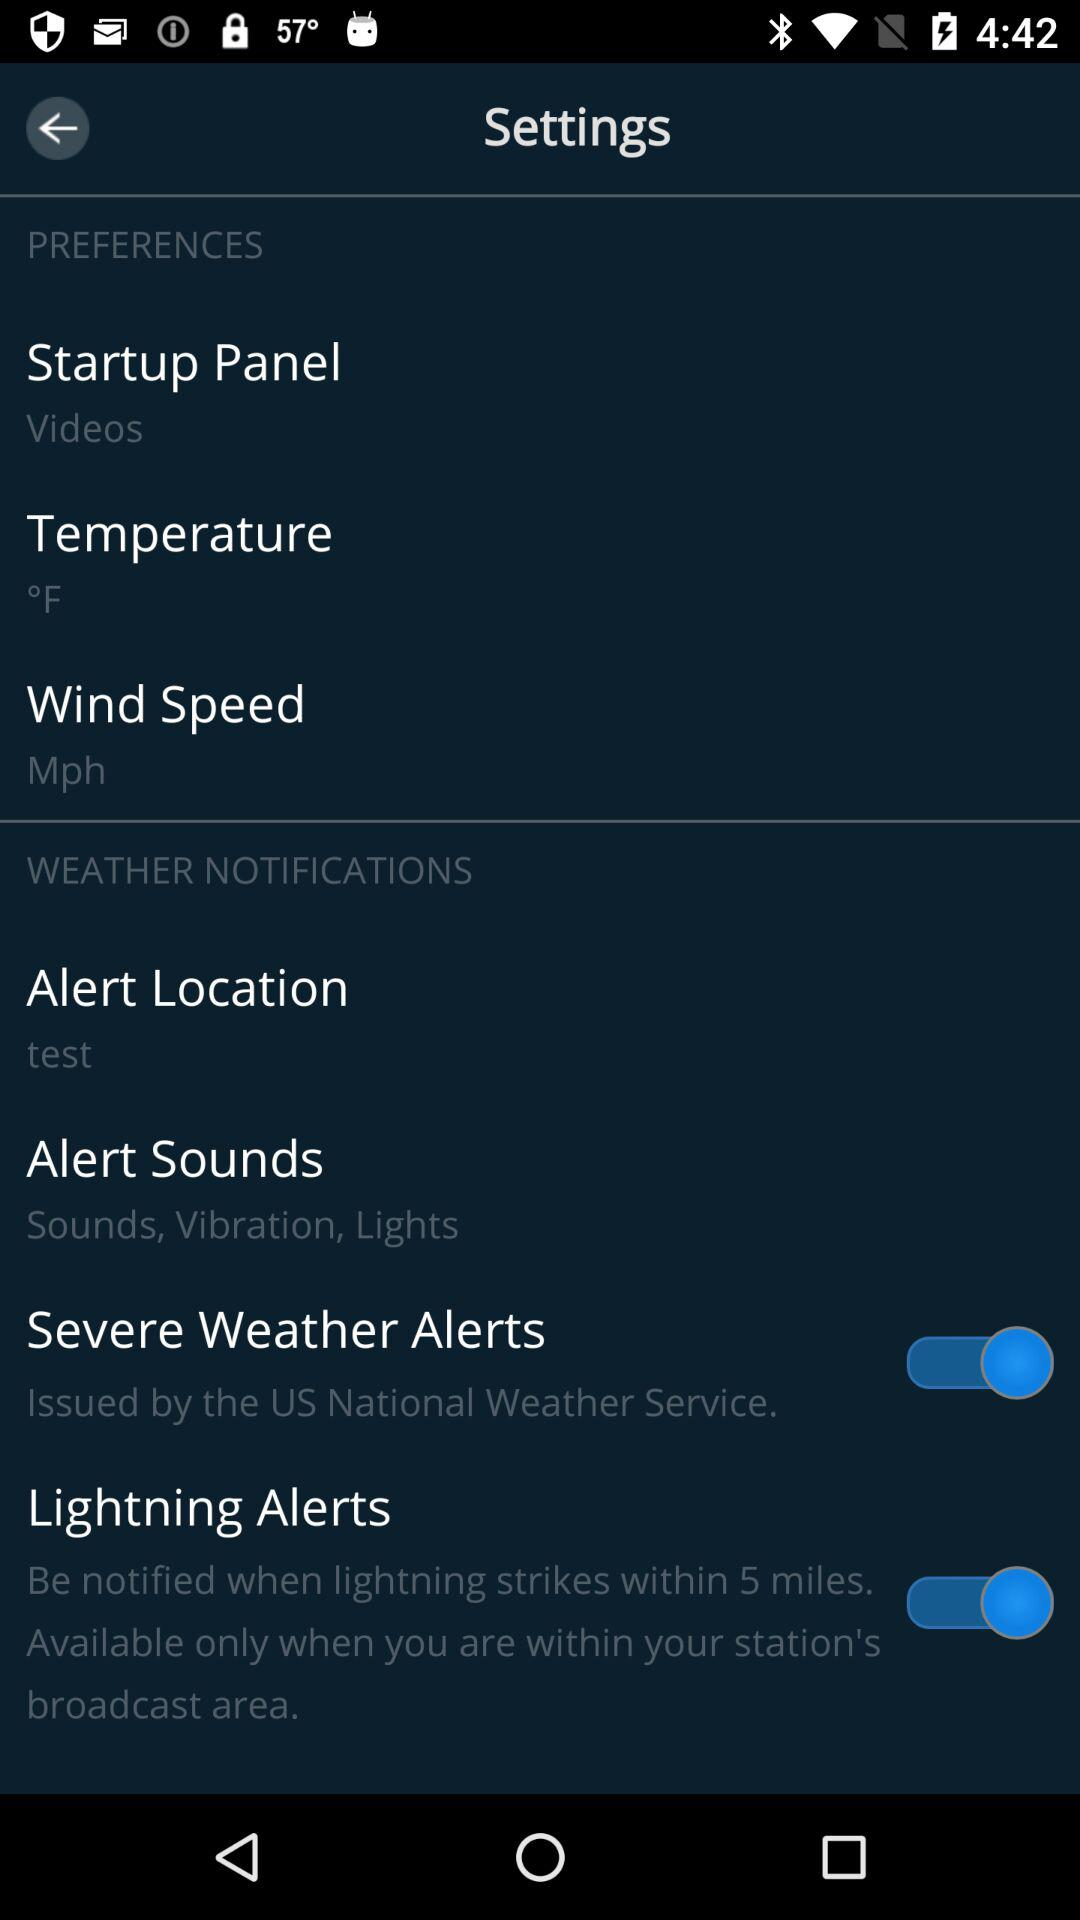What is the status of "Severe Weather Alerts"? The status is "on". 